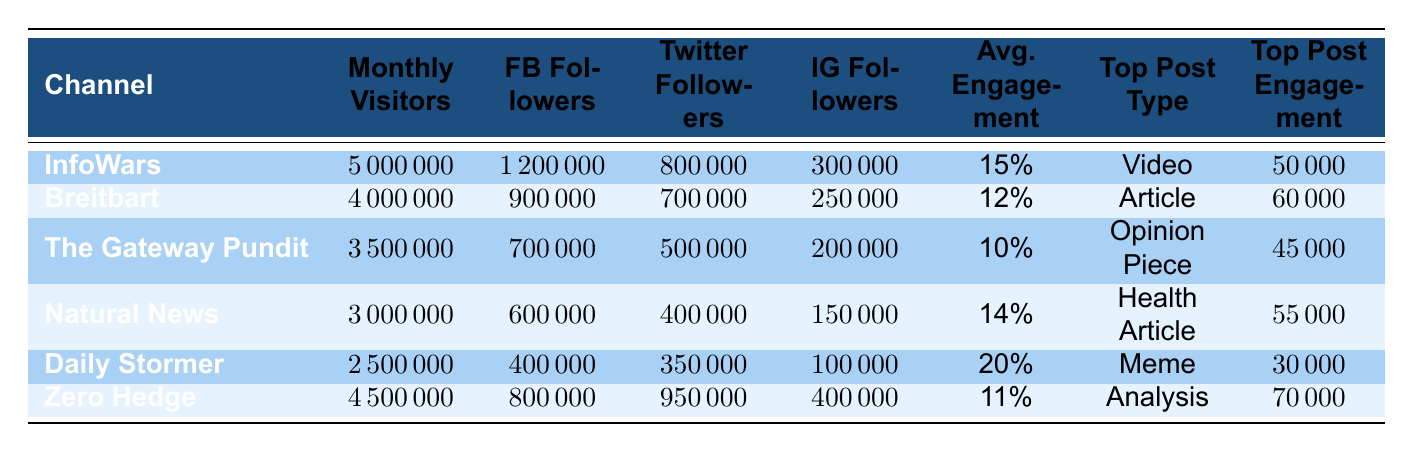What is the monthly visitor count for InfoWars? The table shows that the monthly visitors for InfoWars is listed in the corresponding row under the "Monthly Visitors" column. It states 5,000,000.
Answer: 5,000,000 Which channel has the highest average engagement rate? By looking at the "Avg. Engagement" column, Daily Stormer has the highest engagement rate at 20%.
Answer: Daily Stormer What is the total number of social media followers for The Gateway Pundit? To find the total followers, sum the numbers from the Facebook, Twitter, and Instagram columns for The Gateway Pundit: 700,000 (FB) + 500,000 (Twitter) + 200,000 (IG) = 1,400,000.
Answer: 1,400,000 Does Natural News have more monthly visitors than Breitbart? Comparing the "Monthly Visitors" count, Natural News has 3,000,000 while Breitbart has 4,000,000, indicating that Natural News does not have more visitors.
Answer: No What type of post has the highest engagement across all channels? By analyzing the "Top Post Engagement", Zero Hedge has the highest engagement with 70,000 compared to others.
Answer: Analysis What is the difference in monthly visitors between Daily Stormer and Natural News? Daily Stormer has 2,500,000 visitors and Natural News has 3,000,000. The difference is 3,000,000 - 2,500,000 = 500,000.
Answer: 500,000 Which channel has the most Facebook followers? Looking at the "FB Followers" column, InfoWars has the most with 1,200,000 followers.
Answer: InfoWars What is the average engagement rate for channels that focus on articles? The channels focused on articles are Breitbart and Zero Hedge, with engagement rates of 12% and 11% respectively. The average is (12 + 11) / 2 = 11.5%.
Answer: 11.5% Is it true that the top post type for The Gateway Pundit is a video? The table indicates that the top post type for The Gateway Pundit is "Opinion Piece", which is not a video.
Answer: No Which channel has the least amount of Instagram followers? The Instagram followers for each channel show that Daily Stormer has the least with 100,000 followers.
Answer: Daily Stormer 